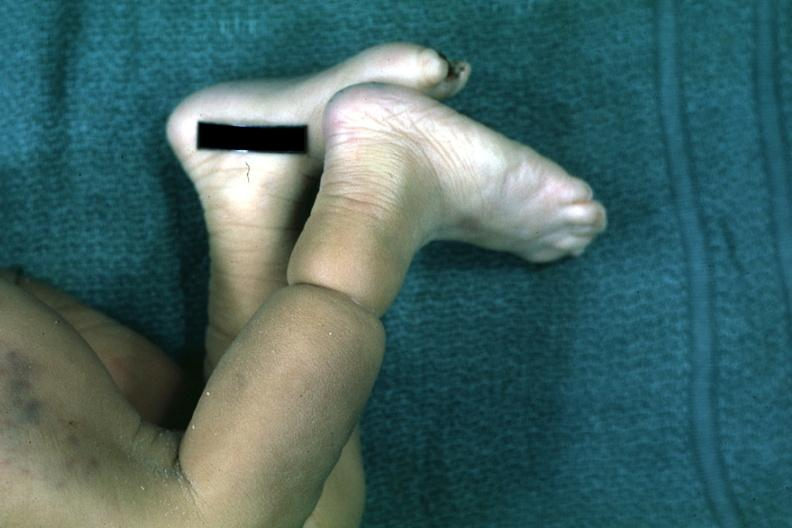what is?
Answer the question using a single word or phrase. That 